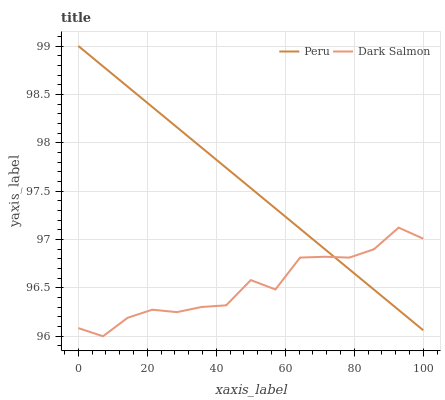Does Dark Salmon have the minimum area under the curve?
Answer yes or no. Yes. Does Peru have the maximum area under the curve?
Answer yes or no. Yes. Does Peru have the minimum area under the curve?
Answer yes or no. No. Is Peru the smoothest?
Answer yes or no. Yes. Is Dark Salmon the roughest?
Answer yes or no. Yes. Is Peru the roughest?
Answer yes or no. No. Does Dark Salmon have the lowest value?
Answer yes or no. Yes. Does Peru have the lowest value?
Answer yes or no. No. Does Peru have the highest value?
Answer yes or no. Yes. Does Dark Salmon intersect Peru?
Answer yes or no. Yes. Is Dark Salmon less than Peru?
Answer yes or no. No. Is Dark Salmon greater than Peru?
Answer yes or no. No. 